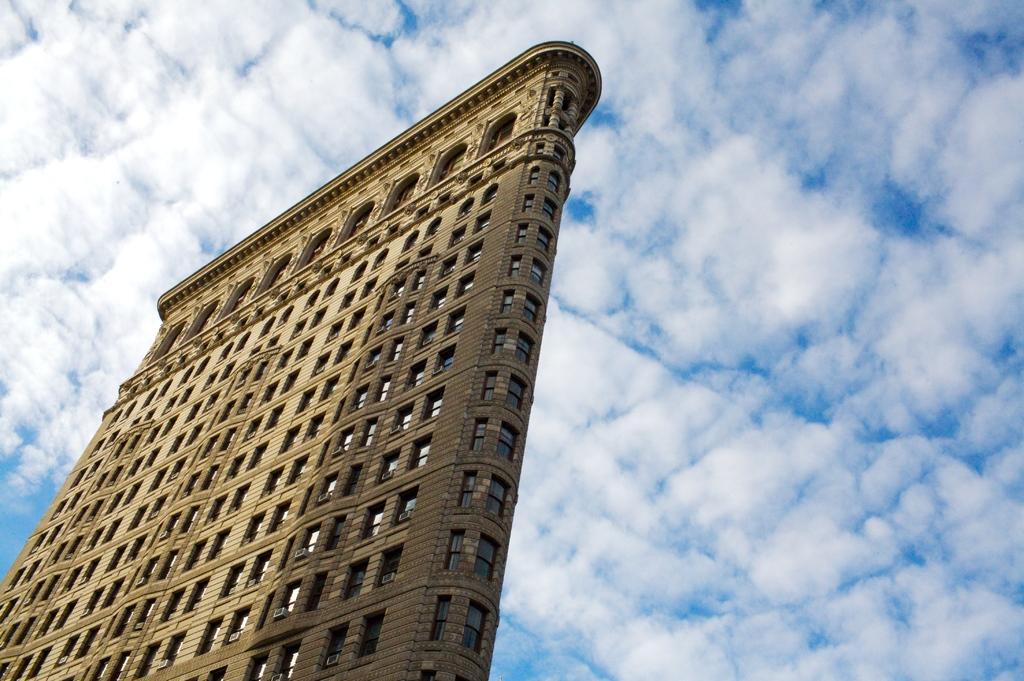Please provide a concise description of this image. In the center of the image there is a building. In the background there is sky. 